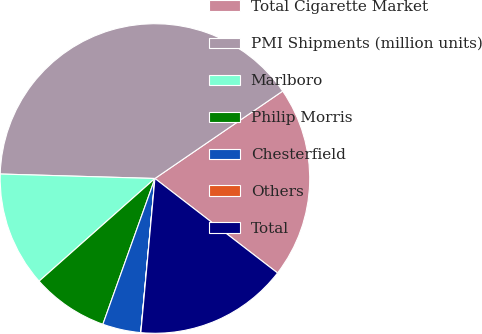Convert chart. <chart><loc_0><loc_0><loc_500><loc_500><pie_chart><fcel>Total Cigarette Market<fcel>PMI Shipments (million units)<fcel>Marlboro<fcel>Philip Morris<fcel>Chesterfield<fcel>Others<fcel>Total<nl><fcel>20.0%<fcel>39.99%<fcel>12.0%<fcel>8.0%<fcel>4.0%<fcel>0.01%<fcel>16.0%<nl></chart> 